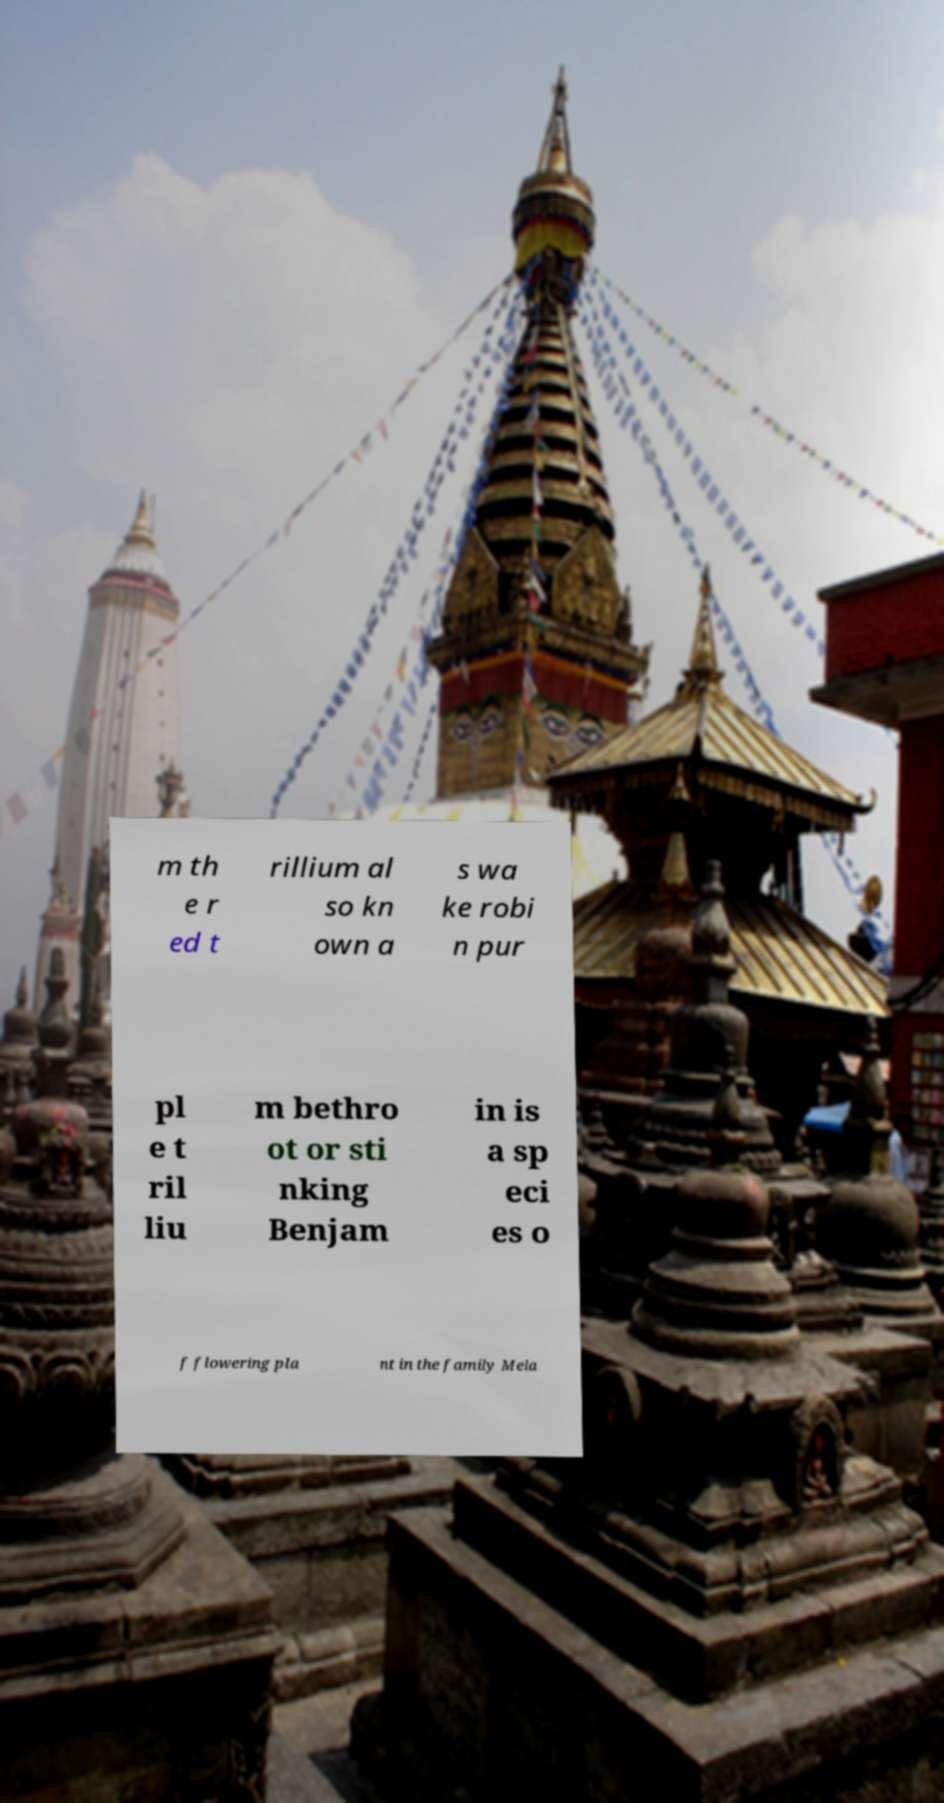For documentation purposes, I need the text within this image transcribed. Could you provide that? m th e r ed t rillium al so kn own a s wa ke robi n pur pl e t ril liu m bethro ot or sti nking Benjam in is a sp eci es o f flowering pla nt in the family Mela 